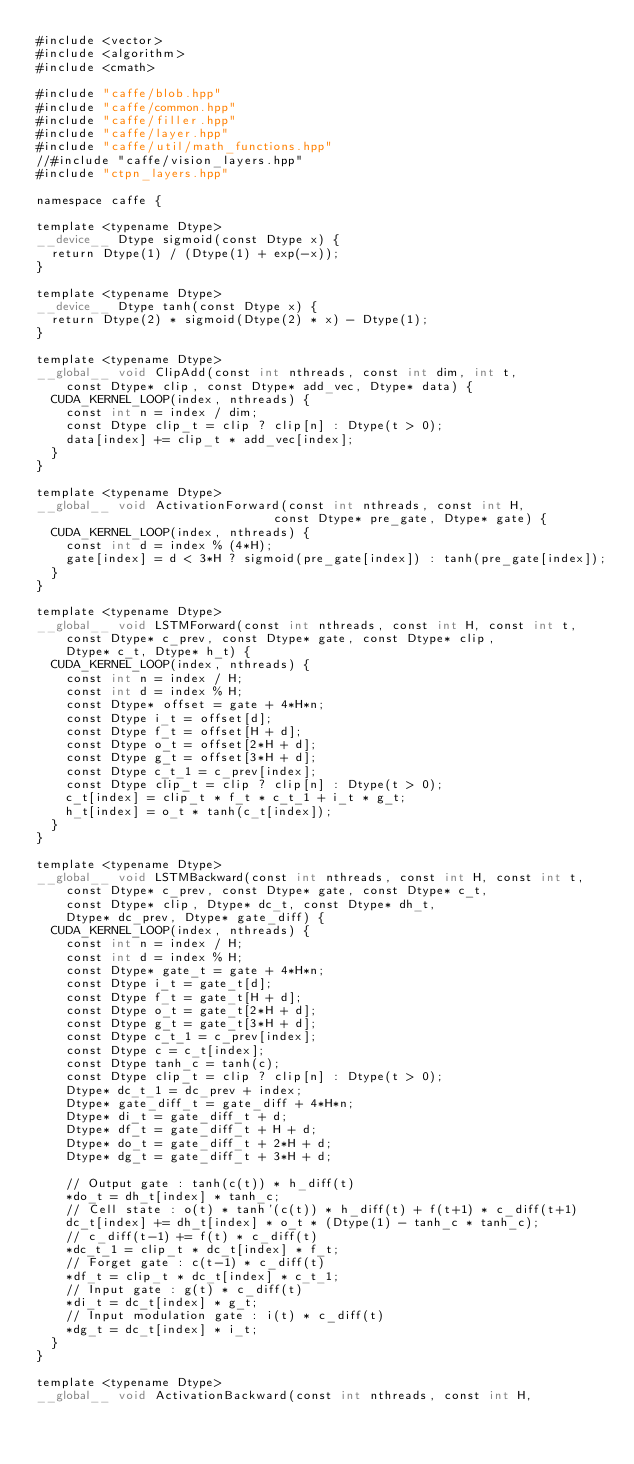Convert code to text. <code><loc_0><loc_0><loc_500><loc_500><_Cuda_>#include <vector>
#include <algorithm>
#include <cmath>

#include "caffe/blob.hpp"
#include "caffe/common.hpp"
#include "caffe/filler.hpp"
#include "caffe/layer.hpp"
#include "caffe/util/math_functions.hpp"
//#include "caffe/vision_layers.hpp"
#include "ctpn_layers.hpp"

namespace caffe {

template <typename Dtype>
__device__ Dtype sigmoid(const Dtype x) {
  return Dtype(1) / (Dtype(1) + exp(-x));
}

template <typename Dtype>
__device__ Dtype tanh(const Dtype x) {
  return Dtype(2) * sigmoid(Dtype(2) * x) - Dtype(1);
}

template <typename Dtype>
__global__ void ClipAdd(const int nthreads, const int dim, int t,
    const Dtype* clip, const Dtype* add_vec, Dtype* data) {
  CUDA_KERNEL_LOOP(index, nthreads) {
    const int n = index / dim;
    const Dtype clip_t = clip ? clip[n] : Dtype(t > 0);
    data[index] += clip_t * add_vec[index];
  }
}

template <typename Dtype>
__global__ void ActivationForward(const int nthreads, const int H,
                                const Dtype* pre_gate, Dtype* gate) {
  CUDA_KERNEL_LOOP(index, nthreads) {
    const int d = index % (4*H);
    gate[index] = d < 3*H ? sigmoid(pre_gate[index]) : tanh(pre_gate[index]);
  }
}

template <typename Dtype>
__global__ void LSTMForward(const int nthreads, const int H, const int t,
    const Dtype* c_prev, const Dtype* gate, const Dtype* clip,
    Dtype* c_t, Dtype* h_t) {
  CUDA_KERNEL_LOOP(index, nthreads) {
    const int n = index / H;
    const int d = index % H;
    const Dtype* offset = gate + 4*H*n;
    const Dtype i_t = offset[d];
    const Dtype f_t = offset[H + d];
    const Dtype o_t = offset[2*H + d];
    const Dtype g_t = offset[3*H + d];
    const Dtype c_t_1 = c_prev[index];
    const Dtype clip_t = clip ? clip[n] : Dtype(t > 0);
    c_t[index] = clip_t * f_t * c_t_1 + i_t * g_t;
    h_t[index] = o_t * tanh(c_t[index]);
  }
}

template <typename Dtype>
__global__ void LSTMBackward(const int nthreads, const int H, const int t, 
    const Dtype* c_prev, const Dtype* gate, const Dtype* c_t, 
    const Dtype* clip, Dtype* dc_t, const Dtype* dh_t, 
    Dtype* dc_prev, Dtype* gate_diff) {
  CUDA_KERNEL_LOOP(index, nthreads) {
    const int n = index / H;
    const int d = index % H;
    const Dtype* gate_t = gate + 4*H*n;
    const Dtype i_t = gate_t[d];
    const Dtype f_t = gate_t[H + d];
    const Dtype o_t = gate_t[2*H + d];
    const Dtype g_t = gate_t[3*H + d];
    const Dtype c_t_1 = c_prev[index];
    const Dtype c = c_t[index];
    const Dtype tanh_c = tanh(c);
    const Dtype clip_t = clip ? clip[n] : Dtype(t > 0);
    Dtype* dc_t_1 = dc_prev + index;
    Dtype* gate_diff_t = gate_diff + 4*H*n;
    Dtype* di_t = gate_diff_t + d;
    Dtype* df_t = gate_diff_t + H + d;
    Dtype* do_t = gate_diff_t + 2*H + d;
    Dtype* dg_t = gate_diff_t + 3*H + d;
    
    // Output gate : tanh(c(t)) * h_diff(t)
    *do_t = dh_t[index] * tanh_c;
    // Cell state : o(t) * tanh'(c(t)) * h_diff(t) + f(t+1) * c_diff(t+1)
    dc_t[index] += dh_t[index] * o_t * (Dtype(1) - tanh_c * tanh_c);
    // c_diff(t-1) += f(t) * c_diff(t)
    *dc_t_1 = clip_t * dc_t[index] * f_t;
    // Forget gate : c(t-1) * c_diff(t)
    *df_t = clip_t * dc_t[index] * c_t_1;
    // Input gate : g(t) * c_diff(t)
    *di_t = dc_t[index] * g_t;
    // Input modulation gate : i(t) * c_diff(t)
    *dg_t = dc_t[index] * i_t;
  }
}

template <typename Dtype>
__global__ void ActivationBackward(const int nthreads, const int H, </code> 